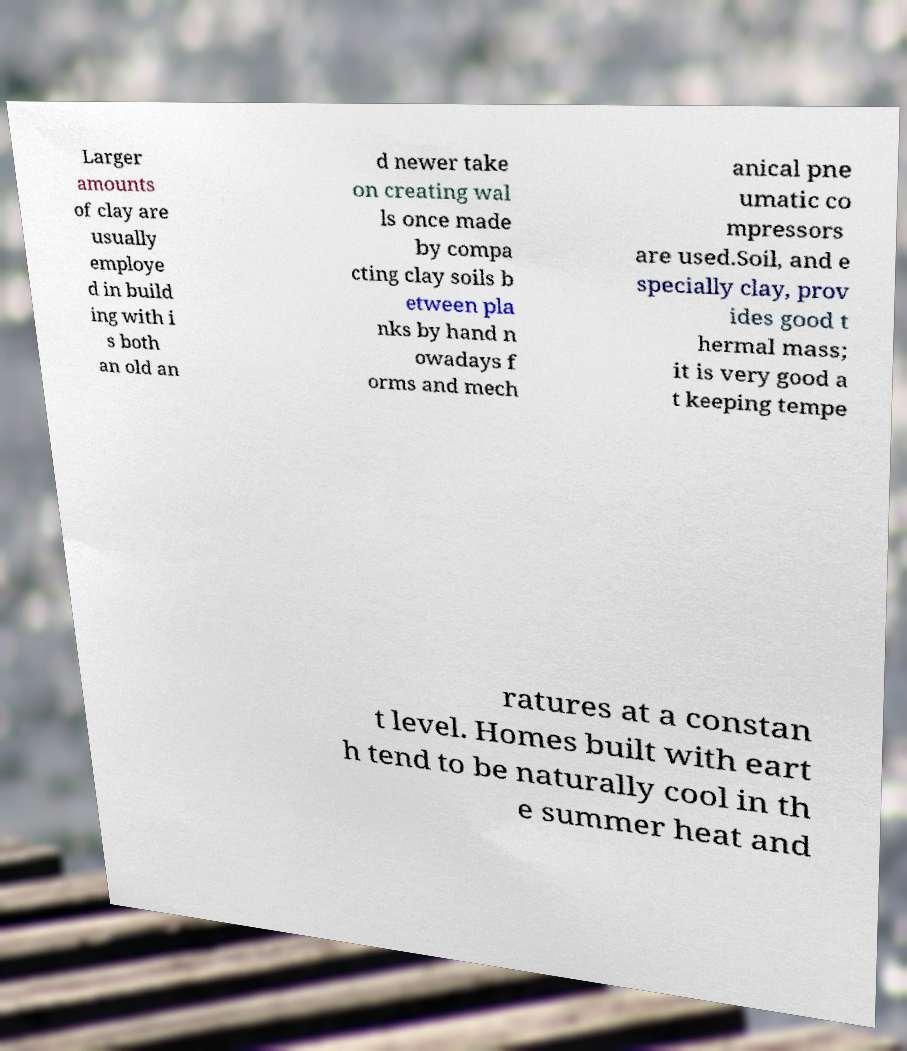Please read and relay the text visible in this image. What does it say? Larger amounts of clay are usually employe d in build ing with i s both an old an d newer take on creating wal ls once made by compa cting clay soils b etween pla nks by hand n owadays f orms and mech anical pne umatic co mpressors are used.Soil, and e specially clay, prov ides good t hermal mass; it is very good a t keeping tempe ratures at a constan t level. Homes built with eart h tend to be naturally cool in th e summer heat and 